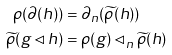<formula> <loc_0><loc_0><loc_500><loc_500>\rho ( \partial ( h ) ) & = \partial _ { n } ( \widetilde { \rho } ( h ) ) \\ \widetilde { \rho } ( g \lhd h ) & = \rho ( g ) \lhd _ { n } \widetilde { \rho } ( h )</formula> 